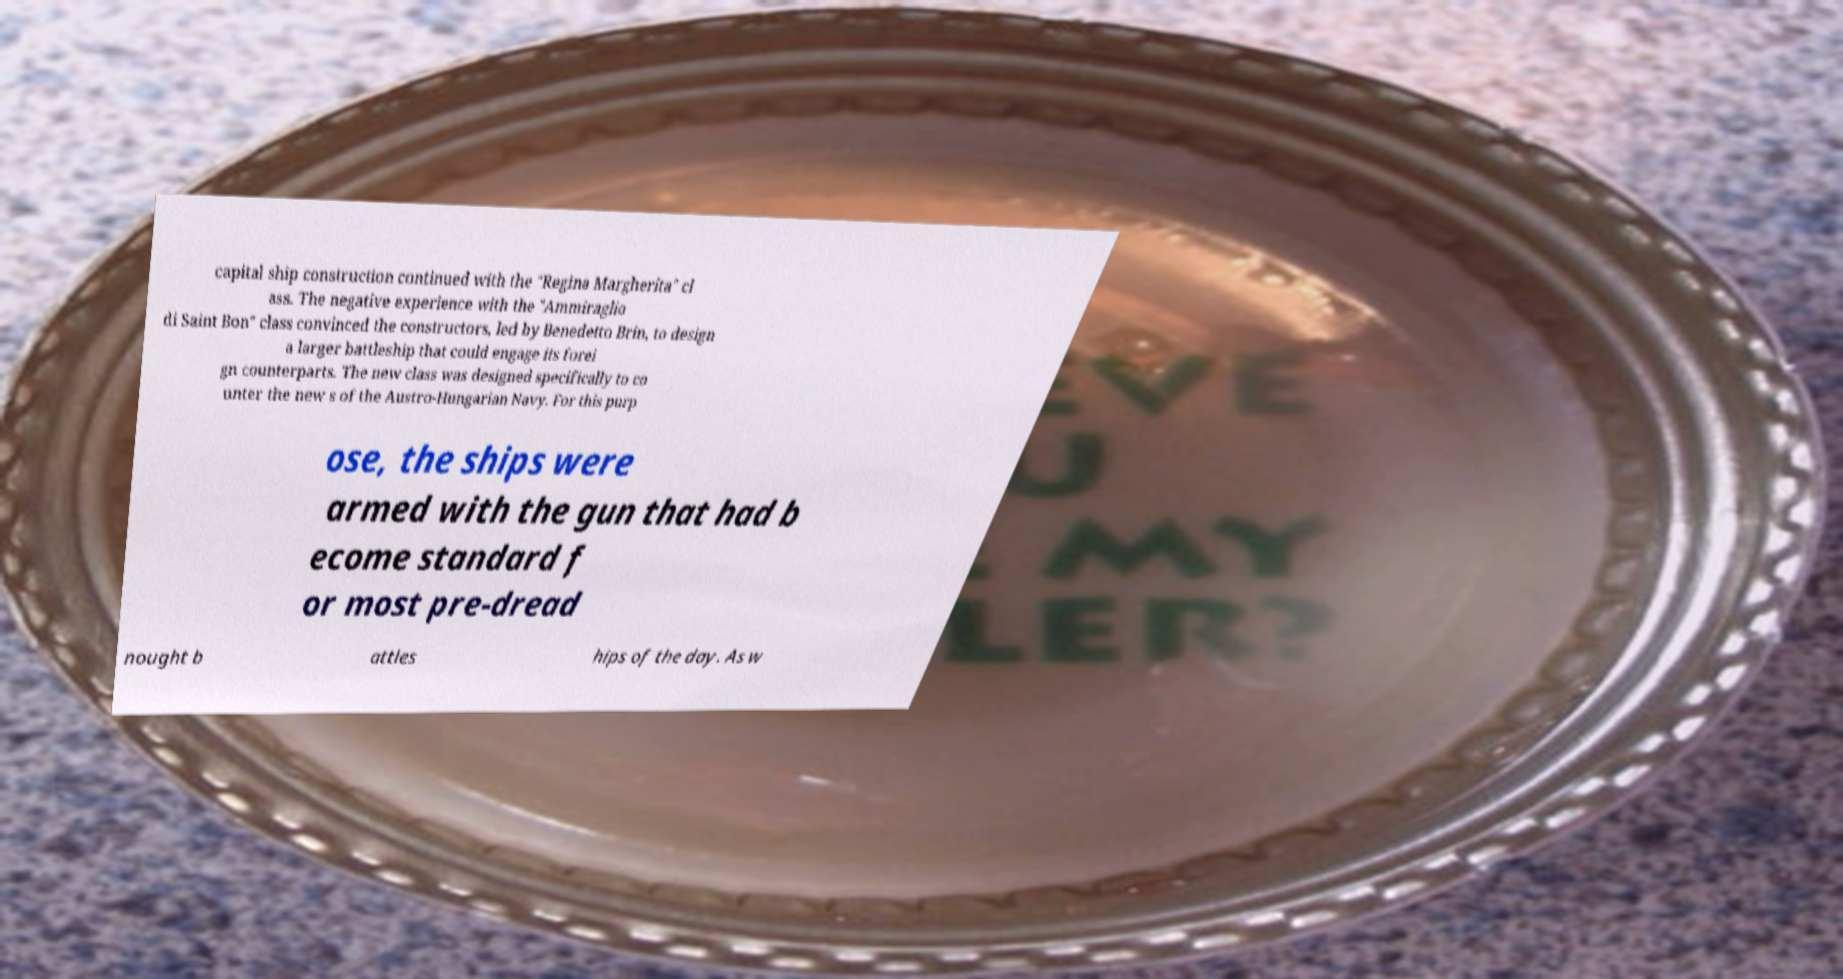Can you read and provide the text displayed in the image?This photo seems to have some interesting text. Can you extract and type it out for me? capital ship construction continued with the "Regina Margherita" cl ass. The negative experience with the "Ammiraglio di Saint Bon" class convinced the constructors, led by Benedetto Brin, to design a larger battleship that could engage its forei gn counterparts. The new class was designed specifically to co unter the new s of the Austro-Hungarian Navy. For this purp ose, the ships were armed with the gun that had b ecome standard f or most pre-dread nought b attles hips of the day. As w 